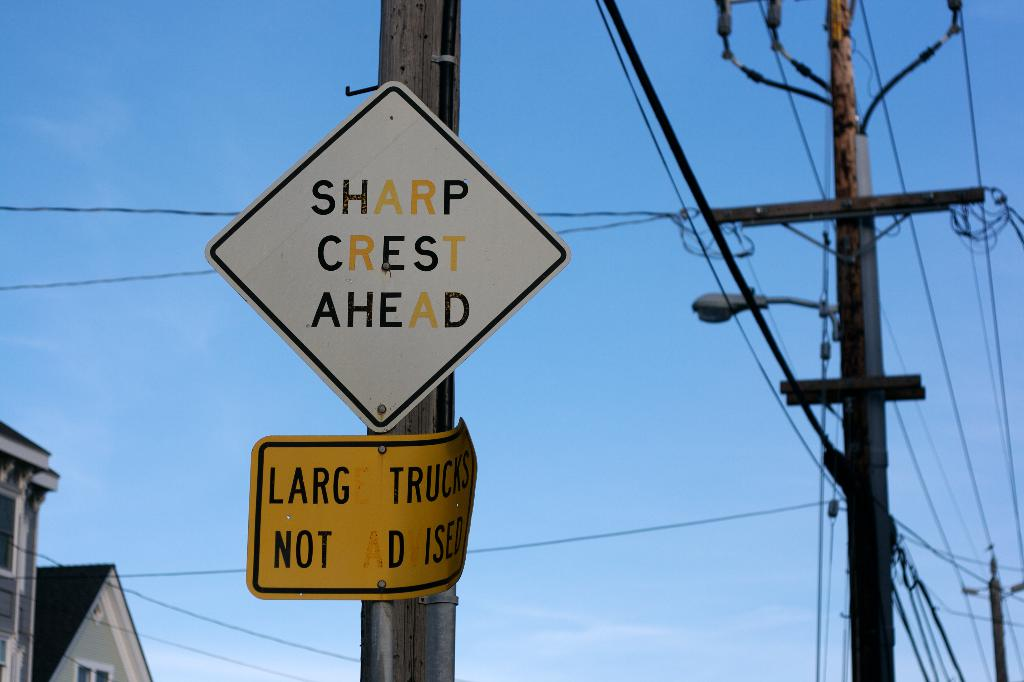In what type of location would you typically find signs like these? Signs like 'Sharp Crest Ahead' and 'Large Trucks Not Advised' are commonly found in suburban or rural areas, especially on roads with unpredictable terrain, such as hilly regions or places with winding roads where visibility of road conditions ahead can be challenging. 